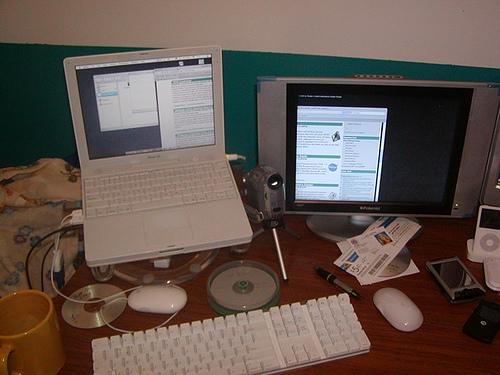Are these all the research books?
Quick response, please. No. How many computers are on?
Give a very brief answer. 2. How many computer keyboards?
Write a very short answer. 2. Do you see disks?
Concise answer only. Yes. What apple devices are shown?
Answer briefly. Computer. 